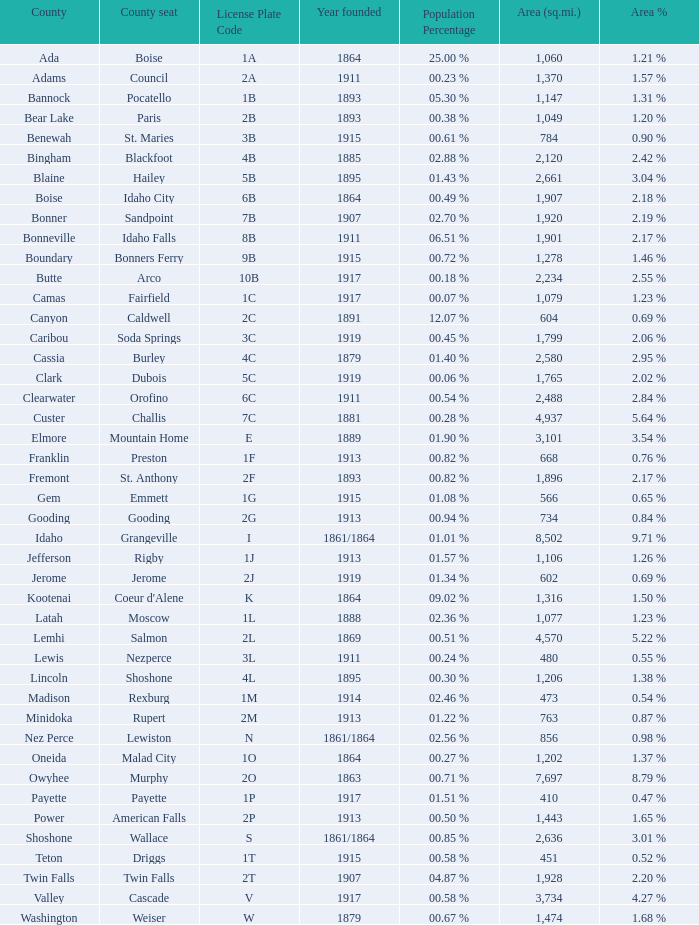What is the country seat for the license plate code 5c? Dubois. 